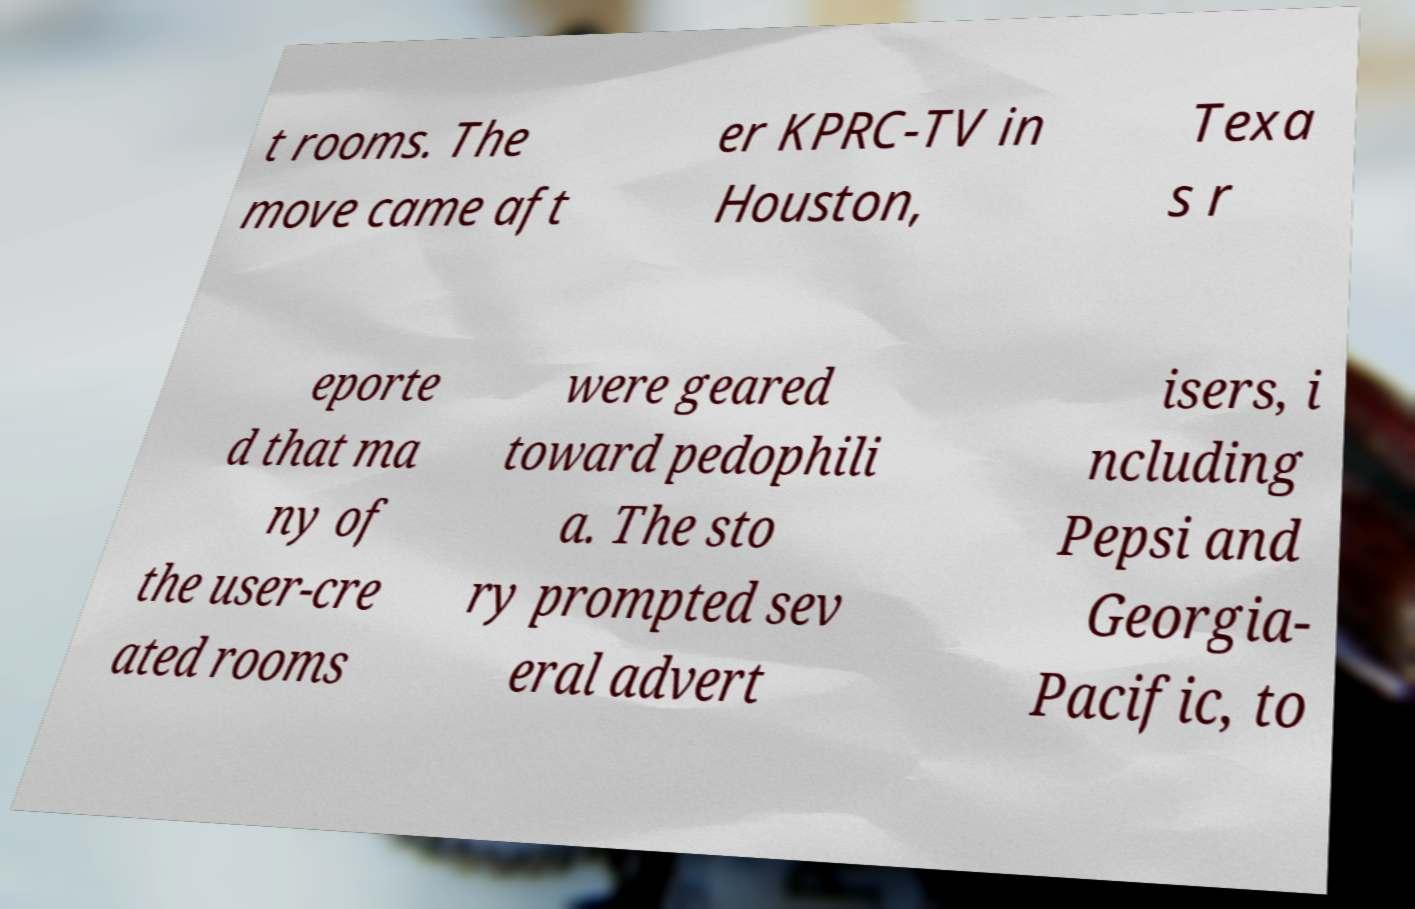Please identify and transcribe the text found in this image. t rooms. The move came aft er KPRC-TV in Houston, Texa s r eporte d that ma ny of the user-cre ated rooms were geared toward pedophili a. The sto ry prompted sev eral advert isers, i ncluding Pepsi and Georgia- Pacific, to 